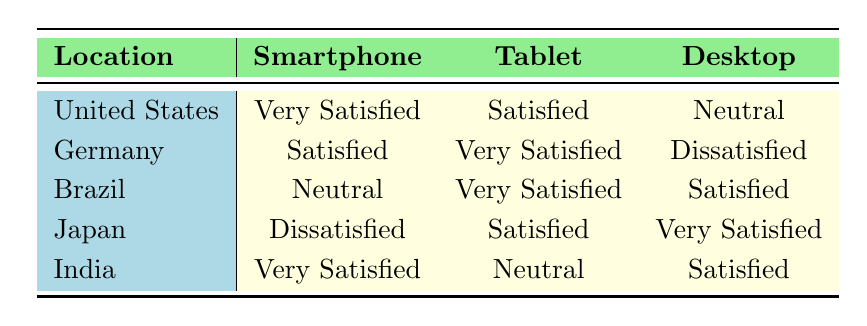What is the satisfaction level of users in the United States using smartphones? The table shows that the satisfaction level of users in the United States using smartphones is "Very Satisfied." This can be directly retrieved from the table under the United States row and the Smartphone column.
Answer: Very Satisfied Which device type has the highest satisfaction level in Germany? In the table, for Germany, the satisfaction levels for each device type are "Satisfied" for Smartphone, "Very Satisfied" for Tablet, and "Dissatisfied" for Desktop. The highest satisfaction level is "Very Satisfied" from the Tablet row.
Answer: Very Satisfied How many device types have a satisfaction level of "Neutral"? From the table, the device types with a "Neutral" satisfaction level are for the United States under "Desktop" and for India under "Tablet." Therefore, there are two device types that have a "Neutral" satisfaction level.
Answer: 2 Is there any device type in Brazil that has a satisfaction level of "Dissatisfied"? The table indicates that Brazil does not have any device type with a "Dissatisfied" satisfaction level as the listed levels are "Neutral" for Smartphone, "Very Satisfied" for Tablet, and "Satisfied" for Desktop.
Answer: No What is the average satisfaction level for Desktop users across all locations? The satisfaction levels for Desktop users are "Neutral" for the United States, "Dissatisfied" for Germany, "Satisfied" for Brazil, "Very Satisfied" for Japan, and "Satisfied" for India. Assigning numerical values (e.g. Very Satisfied=4, Satisfied=3, Neutral=2, Dissatisfied=1), we get: Neutral=2, Dissatisfied=1, Satisfied=3, Very Satisfied=4, Satisfied=3. The sum is (2 + 1 + 3 + 4 + 3) = 13 and there are 5 entries, so the average is 13/5 = 2.6.
Answer: 2.6 